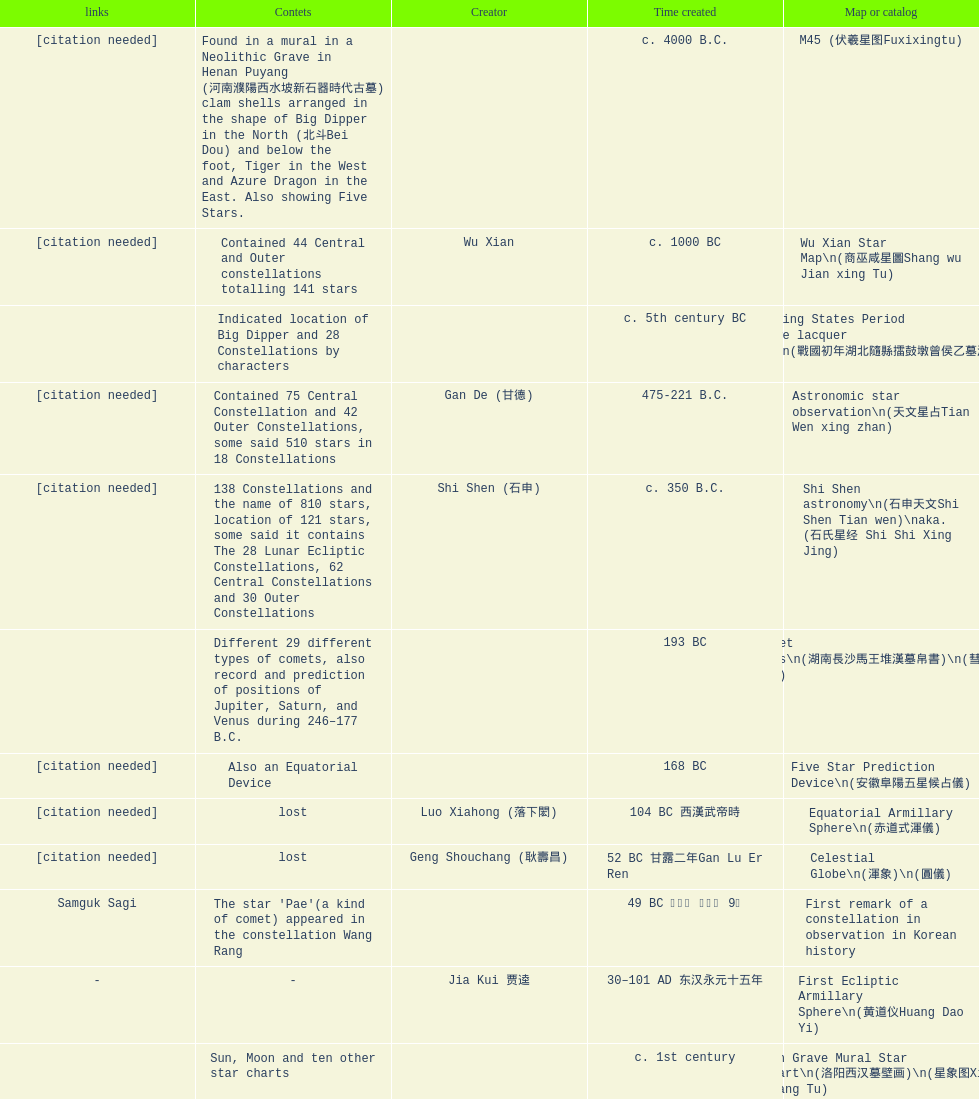Which was the first chinese star map known to have been created? M45 (伏羲星图Fuxixingtu). 